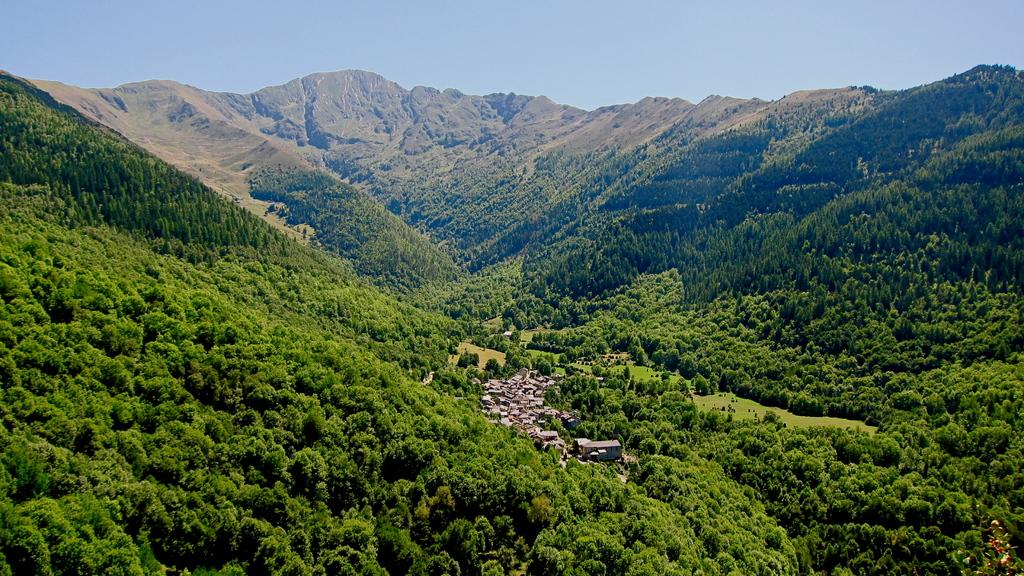What type of natural formation can be seen in the image? There are mountains in the image. What else is present in the image besides the mountains? A: There are buildings in the image. How are the mountains covered? The mountains are covered with trees. What is the condition of the sky in the image? The sky is clear in the image. What type of glove is being played in the image? There is no glove or musical instrument present in the image; it features mountains and buildings. What kind of trouble is depicted in the image? There is no trouble or conflict depicted in the image; it shows a peaceful scene with mountains, buildings, and trees. 